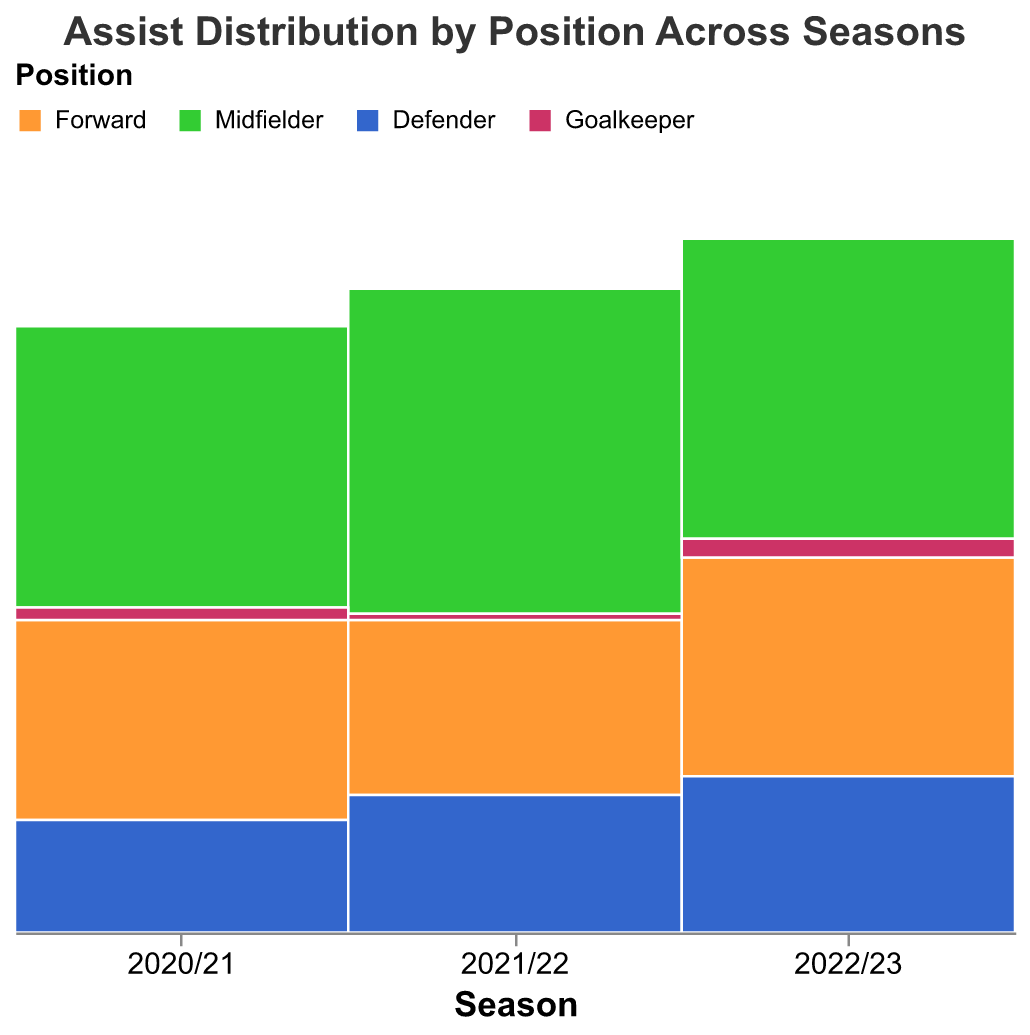What position contributed the most assists in the 2021/22 season? To answer this question, look at the segments for the 2021/22 season. The "Midfielder" segment is the tallest, indicating the highest number of assists.
Answer: Midfielder How many assists did Goalkeepers make in the 2022/23 season? Locate the "Goalkeeper" segment in the 2022/23 season and observe the tooltip or the height of the segment. It's indicated they made 3 assists.
Answer: 3 Comparing the 2020/21 and 2022/23 seasons, did the Forward position increase or decrease in assists? Compare the height of the "Forward" segments between the two seasons. It's clear that the Forward position increased in assists from 32 to 35.
Answer: Increase Which season had the least number of assists from Defenders? To find this, compare the heights of the "Defender" segments across all seasons. The shortest segment is in the 2020/21 season with 18 assists.
Answer: 2020/21 What is the total number of assists made by Midfielders in all three seasons combined? Sum the assist counts for Midfielders across the seasons: 45 (2020/21) + 52 (2021/22) + 48 (2022/23). Therefore, the total is 145.
Answer: 145 Did Goalkeepers' assists increase or decrease from the 2021/22 to the 2022/23 season? Compare the "Goalkeeper" segments for both seasons. The assists increased from 1 to 3.
Answer: Increase What position had a consistent increase in assists over the three seasons? By examining the height of the segments for each position across three seasons, "Defender" shows a consistent increase: 18 (2020/21) -> 22 (2021/22) -> 25 (2022/23).
Answer: Defender How did Midfielders' assist contribution change from 2020/21 to 2021/22? Compare the height of the "Midfielder" segments between the two seasons. The assists increased from 45 to 52.
Answer: Increase Which position had the smallest contribution to assists across all seasons? Determine the segment that is consistently shortest across all seasons. The "Goalkeeper" position has the smallest segments each season.
Answer: Goalkeeper Between the Forward and Midfielder positions, which one had more assists in the 2022/23 season? Compare the segments for both positions in the 2022/23 season. The "Midfielder" segment is taller, indicating more assists (48 vs 35).
Answer: Midfielder 